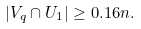<formula> <loc_0><loc_0><loc_500><loc_500>| V _ { q } \cap U _ { 1 } | \geq 0 . 1 6 n .</formula> 